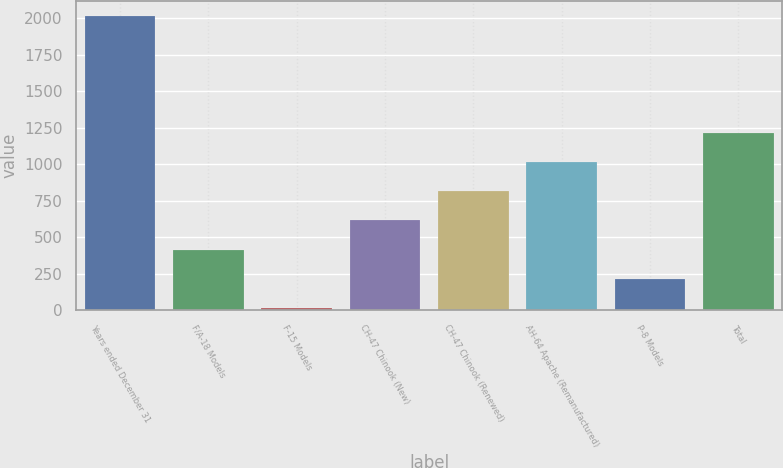<chart> <loc_0><loc_0><loc_500><loc_500><bar_chart><fcel>Years ended December 31<fcel>F/A-18 Models<fcel>F-15 Models<fcel>CH-47 Chinook (New)<fcel>CH-47 Chinook (Renewed)<fcel>AH-64 Apache (Remanufactured)<fcel>P-8 Models<fcel>Total<nl><fcel>2016<fcel>415.2<fcel>15<fcel>615.3<fcel>815.4<fcel>1015.5<fcel>215.1<fcel>1215.6<nl></chart> 